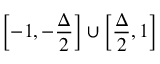Convert formula to latex. <formula><loc_0><loc_0><loc_500><loc_500>\left [ - 1 , - \frac { \Delta } { 2 } \right ] \cup \left [ \frac { \Delta } { 2 } , 1 \right ]</formula> 